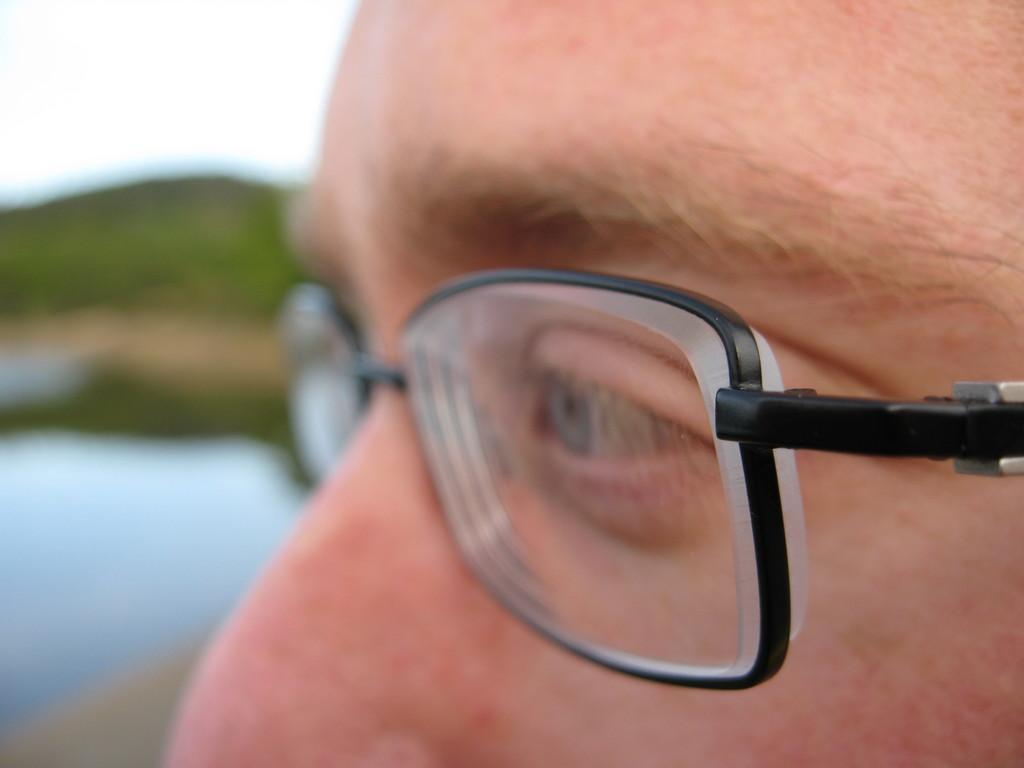What is present in the image? There is a person in the image. Can you describe the person's appearance? The person is wearing spectacles. Is the person in the image using a pencil to write something? There is no pencil present in the image, and the person's activity is not mentioned, so it cannot be determined if they are using a pencil to write something. 